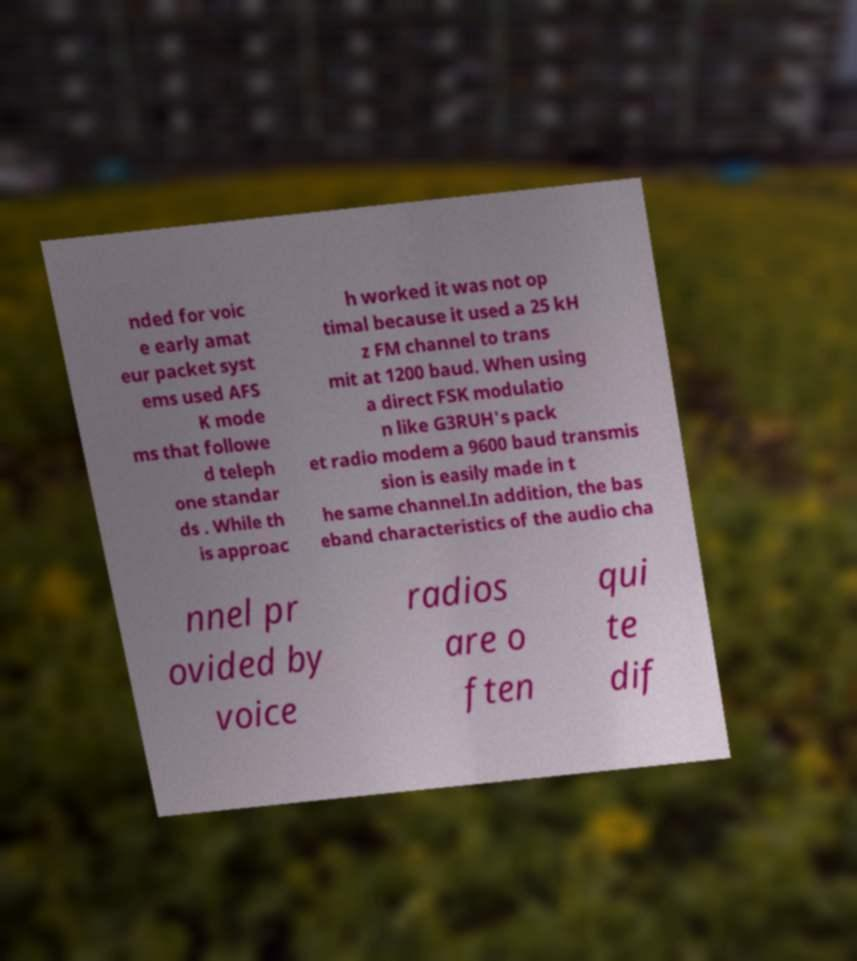Could you assist in decoding the text presented in this image and type it out clearly? nded for voic e early amat eur packet syst ems used AFS K mode ms that followe d teleph one standar ds . While th is approac h worked it was not op timal because it used a 25 kH z FM channel to trans mit at 1200 baud. When using a direct FSK modulatio n like G3RUH's pack et radio modem a 9600 baud transmis sion is easily made in t he same channel.In addition, the bas eband characteristics of the audio cha nnel pr ovided by voice radios are o ften qui te dif 